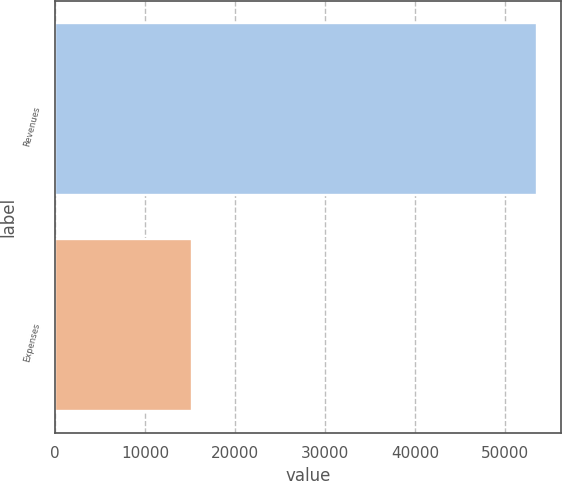<chart> <loc_0><loc_0><loc_500><loc_500><bar_chart><fcel>Revenues<fcel>Expenses<nl><fcel>53532<fcel>15176<nl></chart> 